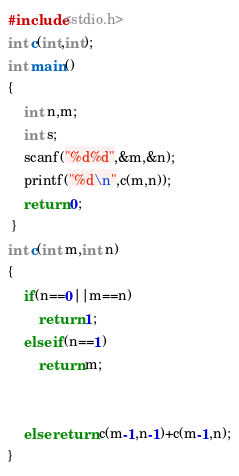Convert code to text. <code><loc_0><loc_0><loc_500><loc_500><_C_>#include<stdio.h>
int c(int,int);
int main()
{
    int n,m;
    int s;
    scanf("%d%d",&m,&n);
    printf("%d\n",c(m,n));
	return 0;
 }
int c(int m,int n)
{
    if(n==0||m==n)
        return 1;
    else if(n==1)
        return m;


    else return c(m-1,n-1)+c(m-1,n);
}</code> 